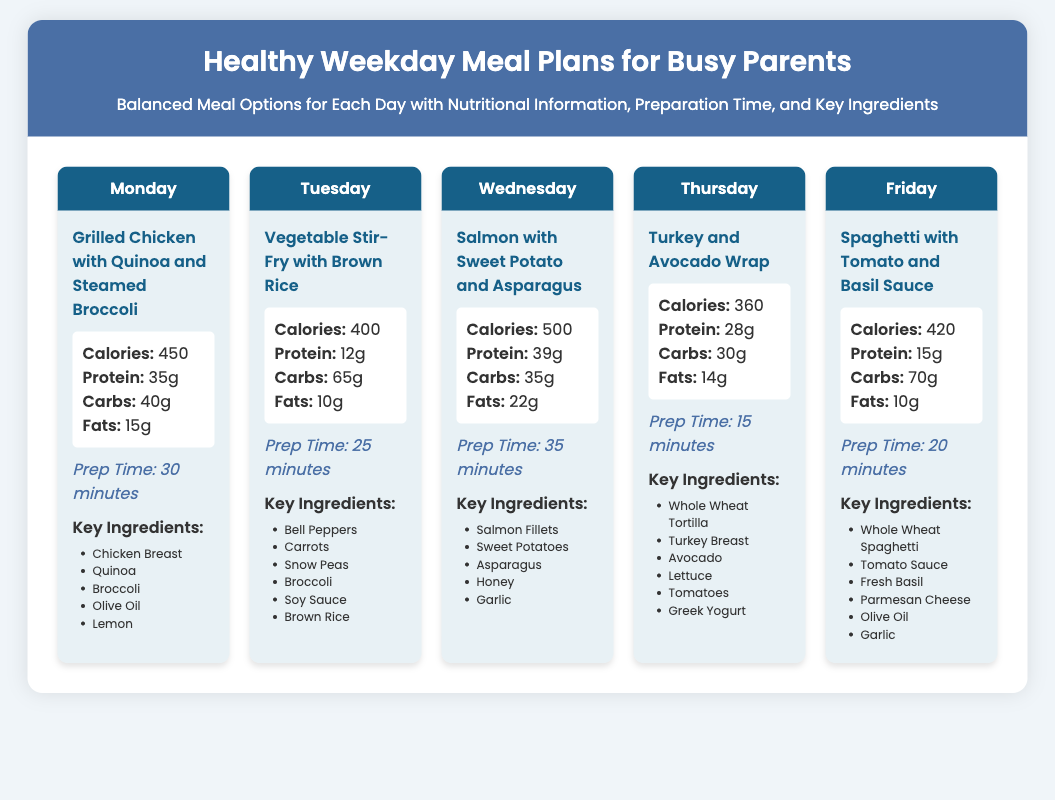What is the meal for Monday? The meal listed for Monday is "Grilled Chicken with Quinoa and Steamed Broccoli."
Answer: Grilled Chicken with Quinoa and Steamed Broccoli What is the prep time for Thursday's meal? The prep time for Thursday's meal is stated to be 15 minutes.
Answer: 15 minutes How many grams of protein are in Wednesday's meal? The document states that Wednesday's meal has 39 grams of protein.
Answer: 39g Which day features a vegetable stir-fry? The day that features a vegetable stir-fry is Tuesday.
Answer: Tuesday What is the total calorie content for the week's meals? The total calories are found by adding the calories for each meal: 450 + 400 + 500 + 360 + 420 = 2130.
Answer: 2130 Which ingredient is common in Monday's and Friday's meals? The common ingredient in both Monday's and Friday's meals is "Olive Oil."
Answer: Olive Oil What color is the header for the meal plans? The color mentioned for the header is blue due to the specific hex value provided.
Answer: Blue Which meal has the highest fat content? The meal with the highest fat content is Wednesday's meal, with 22 grams of fat.
Answer: 22g 